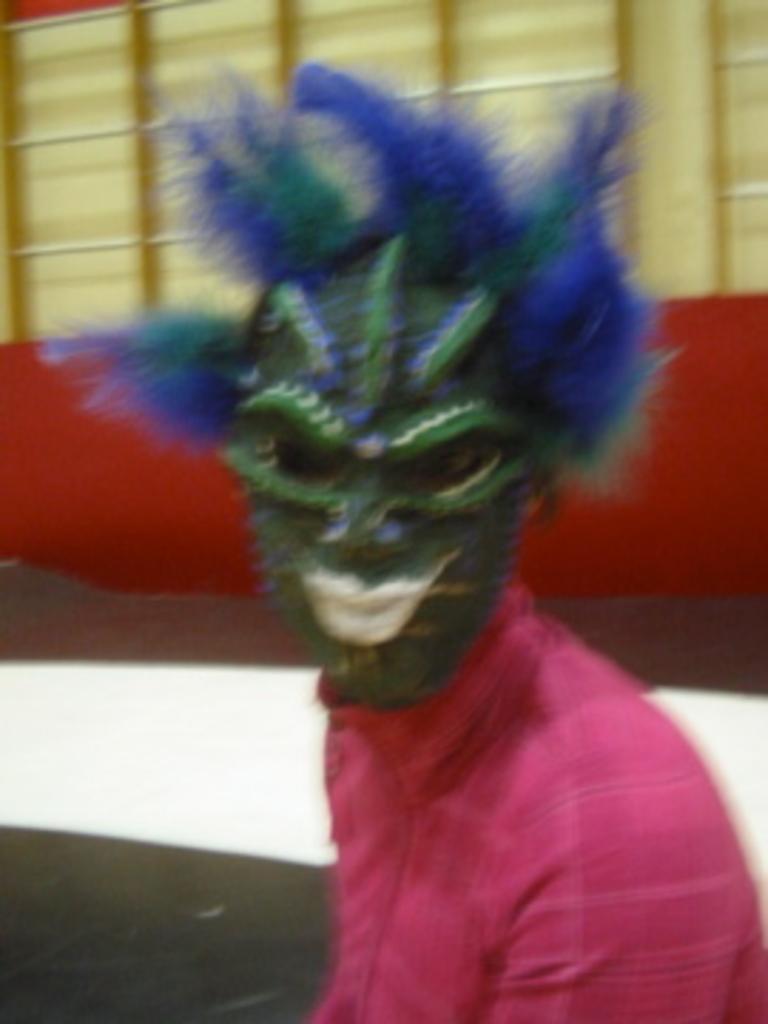Could you give a brief overview of what you see in this image? In this image there is a person in the middle who is having a mask to his face. In the background there is a wall. 